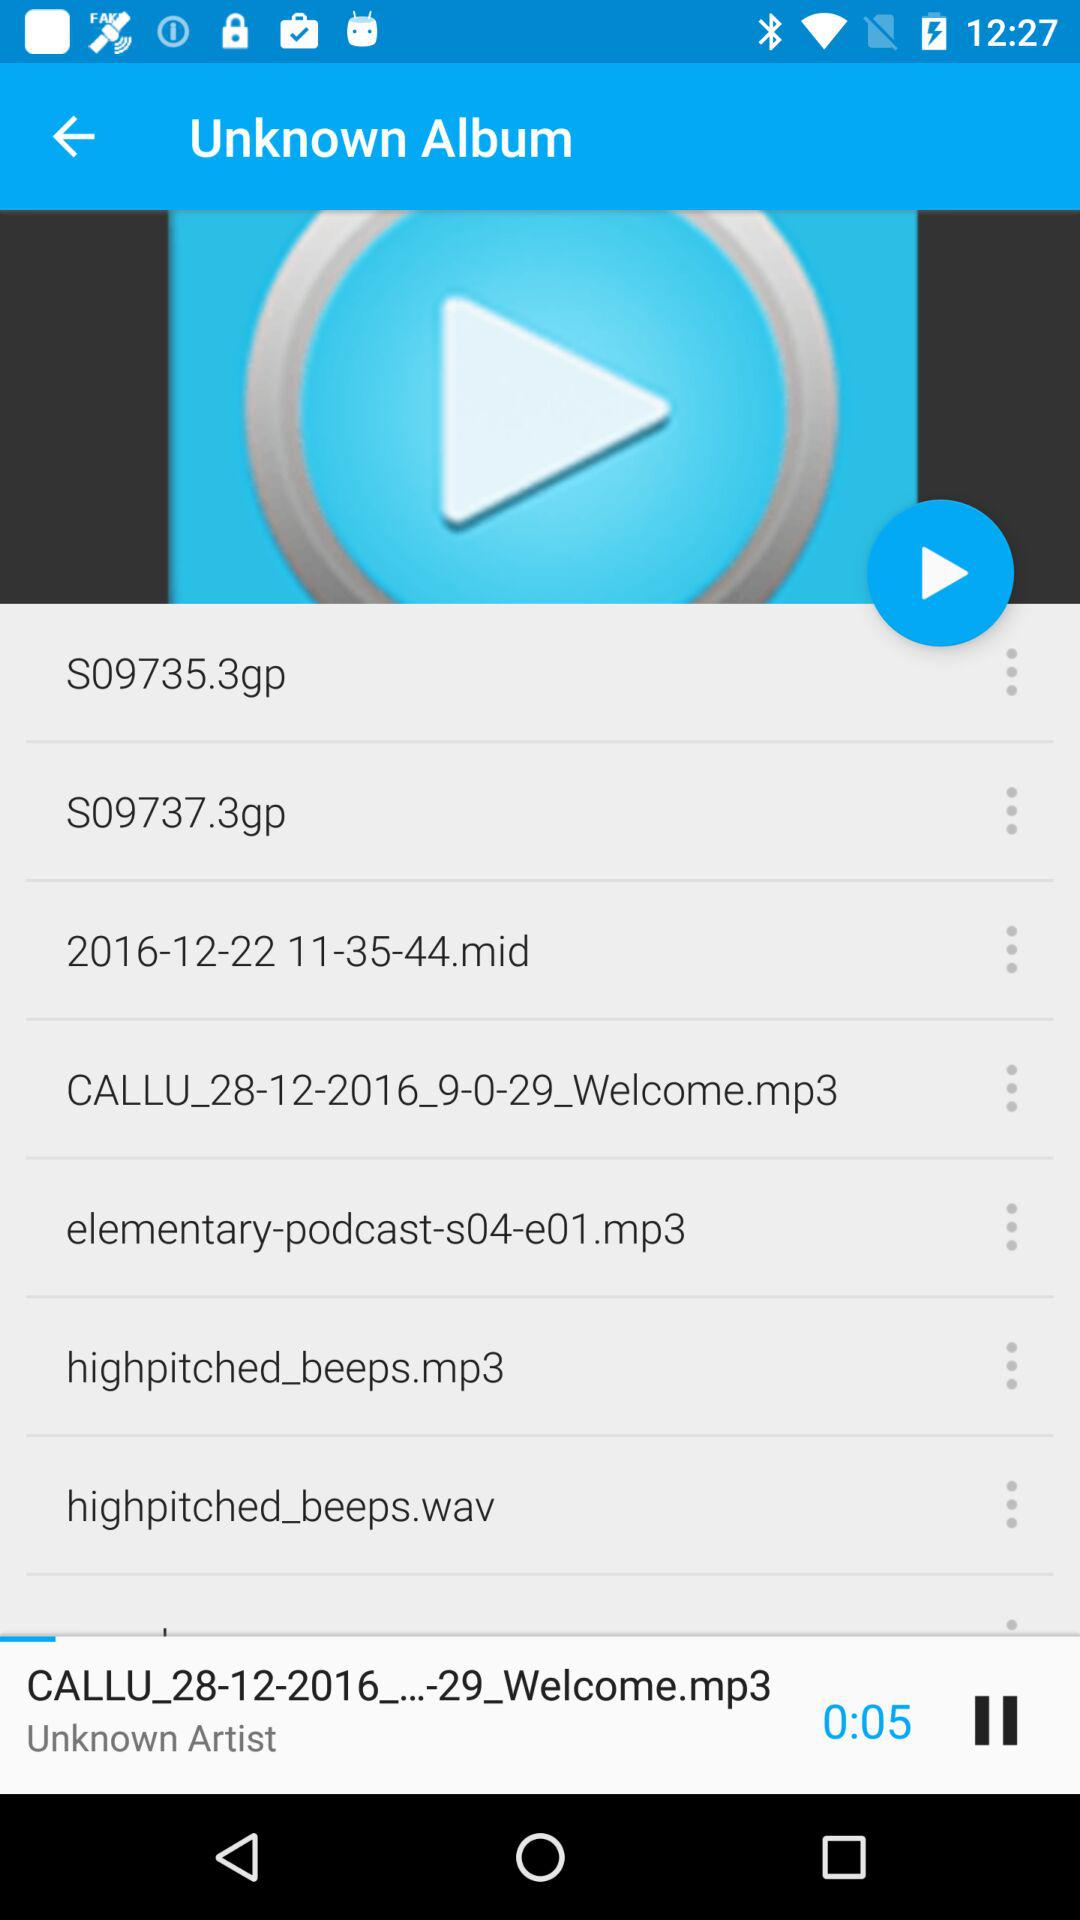When was the album created?
When the provided information is insufficient, respond with <no answer>. <no answer> 